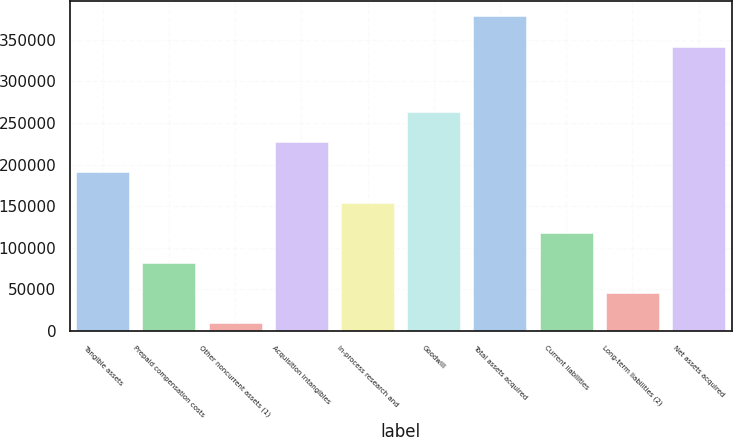<chart> <loc_0><loc_0><loc_500><loc_500><bar_chart><fcel>Tangible assets<fcel>Prepaid compensation costs<fcel>Other noncurrent assets (1)<fcel>Acquisition intangibles<fcel>In-process research and<fcel>Goodwill<fcel>Total assets acquired<fcel>Current liabilities<fcel>Long-term liabilities (2)<fcel>Net assets acquired<nl><fcel>190770<fcel>82032.6<fcel>9541<fcel>227016<fcel>154524<fcel>263262<fcel>378090<fcel>118278<fcel>45786.8<fcel>341844<nl></chart> 